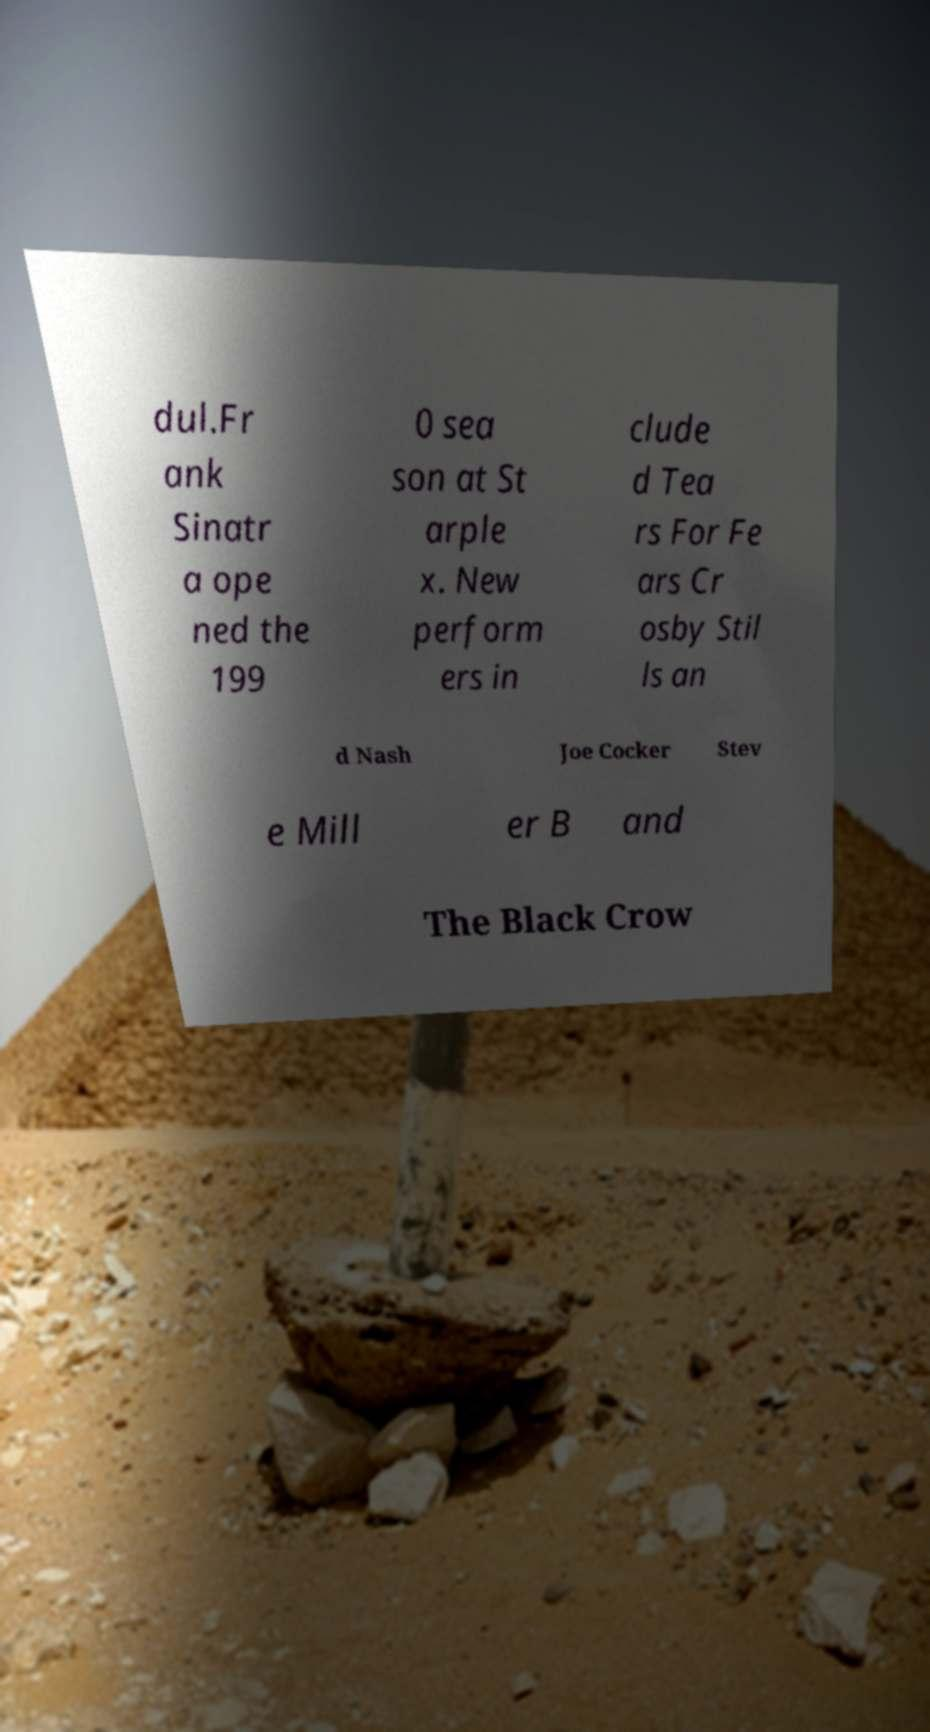What messages or text are displayed in this image? I need them in a readable, typed format. dul.Fr ank Sinatr a ope ned the 199 0 sea son at St arple x. New perform ers in clude d Tea rs For Fe ars Cr osby Stil ls an d Nash Joe Cocker Stev e Mill er B and The Black Crow 